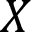<formula> <loc_0><loc_0><loc_500><loc_500>X</formula> 